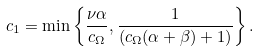Convert formula to latex. <formula><loc_0><loc_0><loc_500><loc_500>c _ { 1 } = \min \left \{ \frac { \nu \alpha } { c _ { \Omega } } , \frac { 1 } { ( c _ { \Omega } ( \alpha + \beta ) + 1 ) } \right \} .</formula> 